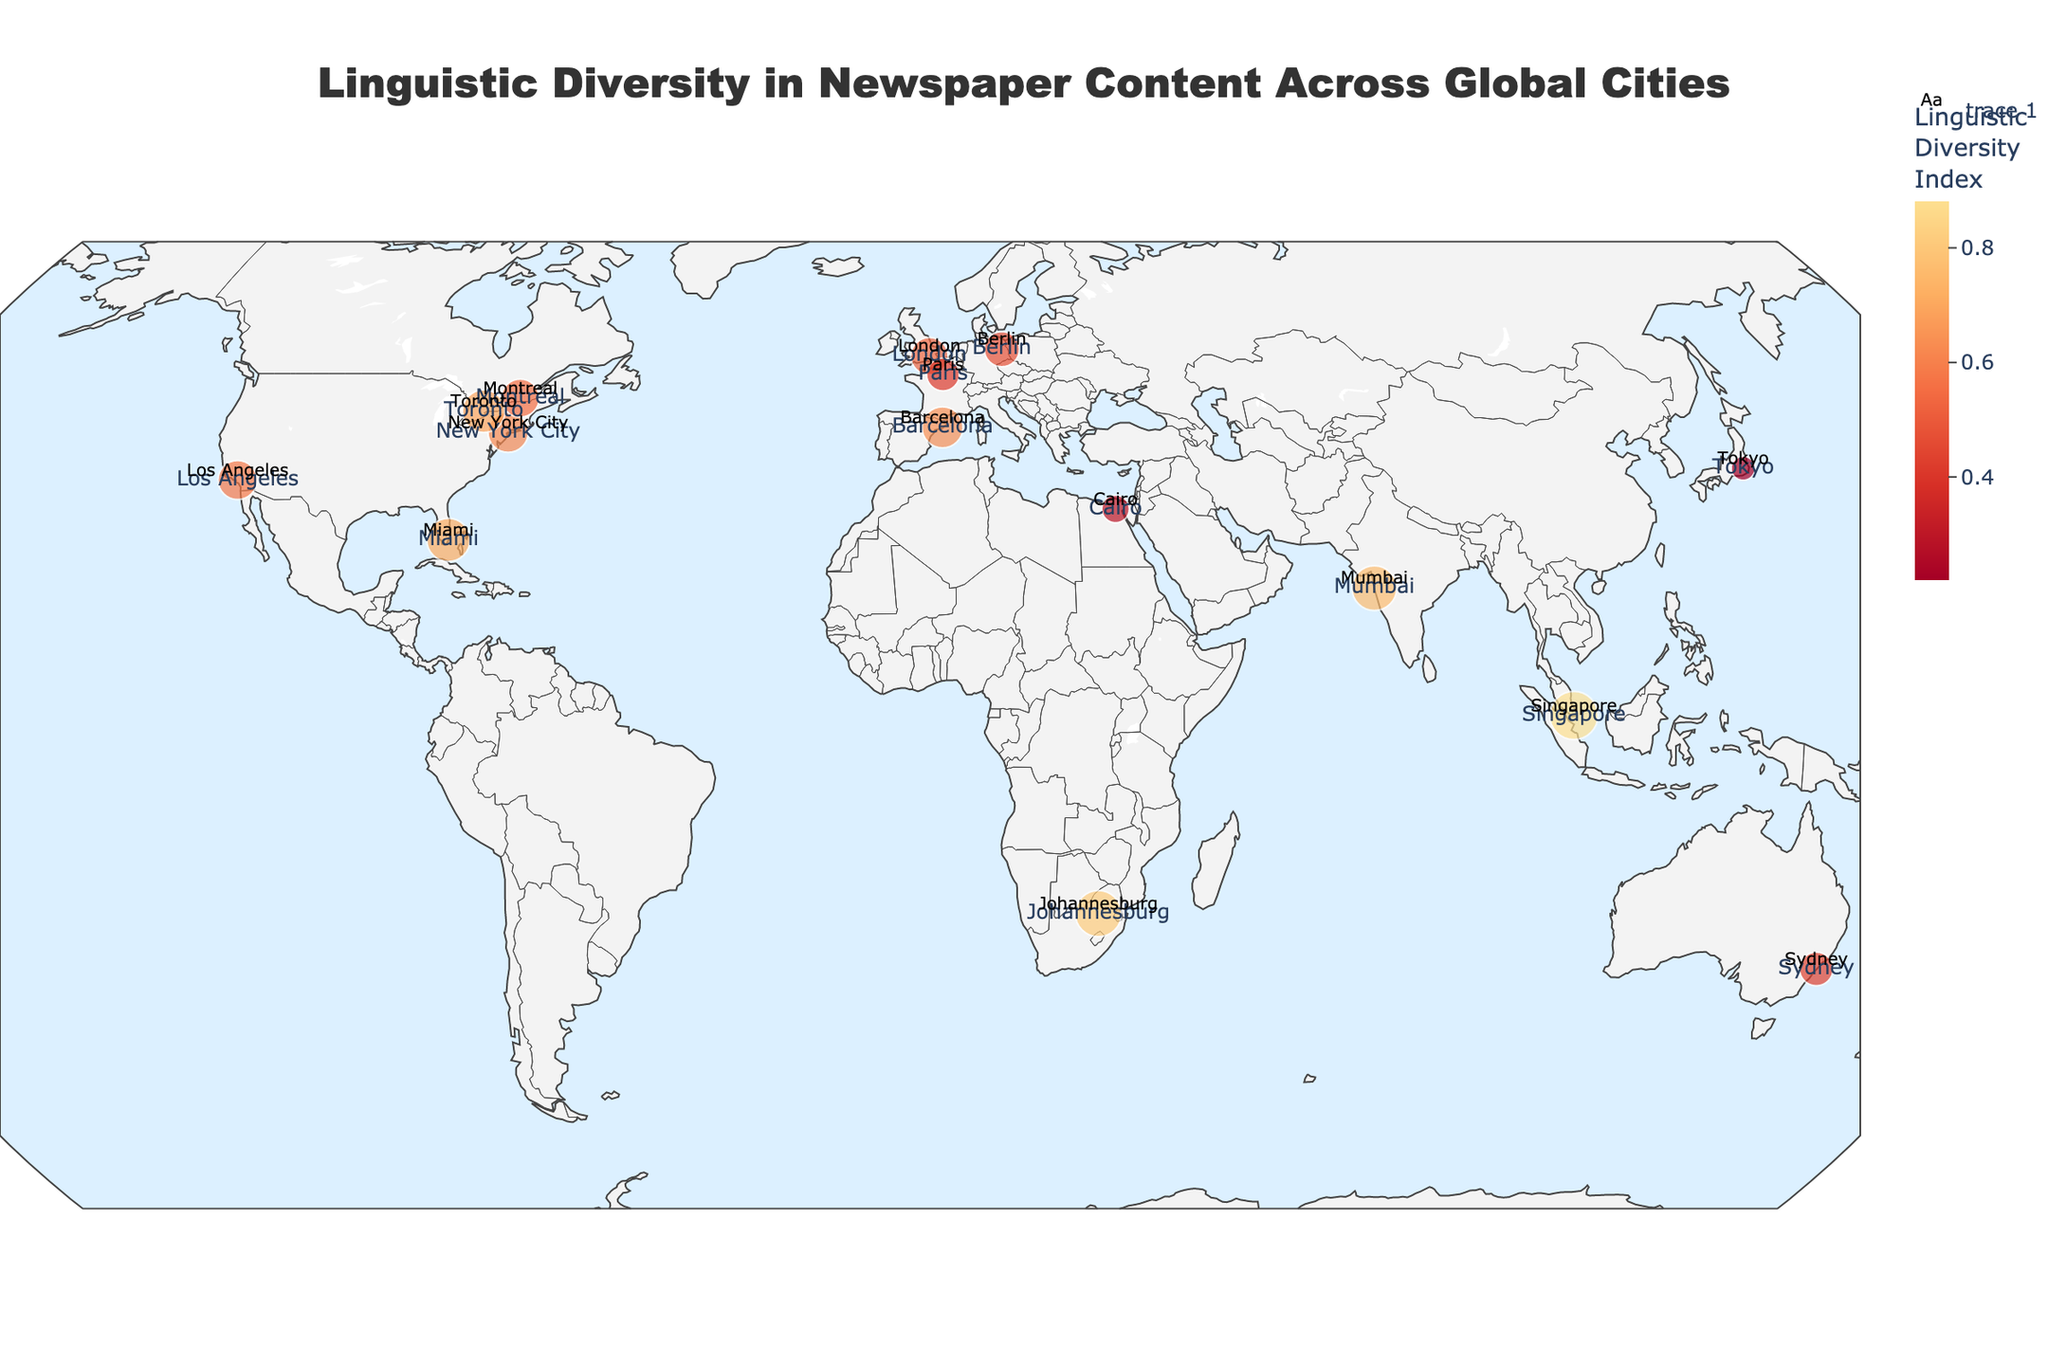Which city has the highest Linguistic Diversity Index? By looking at the size and color of the markers on the map, we can identify which city has the highest Linguistic Diversity Index. The larger and darker the marker, the higher the index.
Answer: Singapore Which city has the lowest Linguistic Diversity Index, and what languages are spoken there? By looking at the smallest and lightest marker on the map, we see that Tokyo has the lowest Linguistic Diversity Index. The languages spoken there are Japanese (Primary), English (Secondary), and Korean (Tertiary).
Answer: Tokyo, Japanese, English, Korean What is the Linguistic Diversity Index range displayed in the plot? The plot uses a color scale to represent the Linguistic Diversity Index values. By observing the range of colors from the legend, we see the index ranges from around 0.22 to 0.88.
Answer: 0.22 to 0.88 Which city in North America has the most diverse newspaper content in terms of languages? By looking at the markers for cities in North America and identifying the one with the largest size and darkest color, we find that Miami stands out.
Answer: Miami Compare the Linguistic Diversity Index of New York City and Los Angeles. Which city is more diverse? By examining the size and color of the markers for New York City and Los Angeles, we see that New York City's marker is both larger and darker, indicating a higher diversity index.
Answer: New York City What is the primary language spoken in Barcelona, and how does its linguistic diversity compare to Paris? From the plot, we see the primary language in Barcelona is Catalan. Comparing the colors and sizes of the markers, Barcelona has a higher Linguistic Diversity Index than Paris.
Answer: Catalan, higher Calculate the average Linguistic Diversity Index for the cities in Canada (Toronto and Montreal). The indices for Toronto and Montreal are 0.69 and 0.55, respectively. The average is (0.69 + 0.55) / 2 = 0.62.
Answer: 0.62 What is the relationship between the location (continent) of a city and its Linguistic Diversity Index? Elements to consider include the color and size of markers on different continents. Generally, cities in regions like North America and Asia tend to have higher indices, while European cities show more variance.
Answer: Varied Identify the city with the closest Linguistic Diversity Index to 0.50 and name its primary language. The city closest to a 0.50 index is Montreal, with a primary language of French.
Answer: Montreal, French 